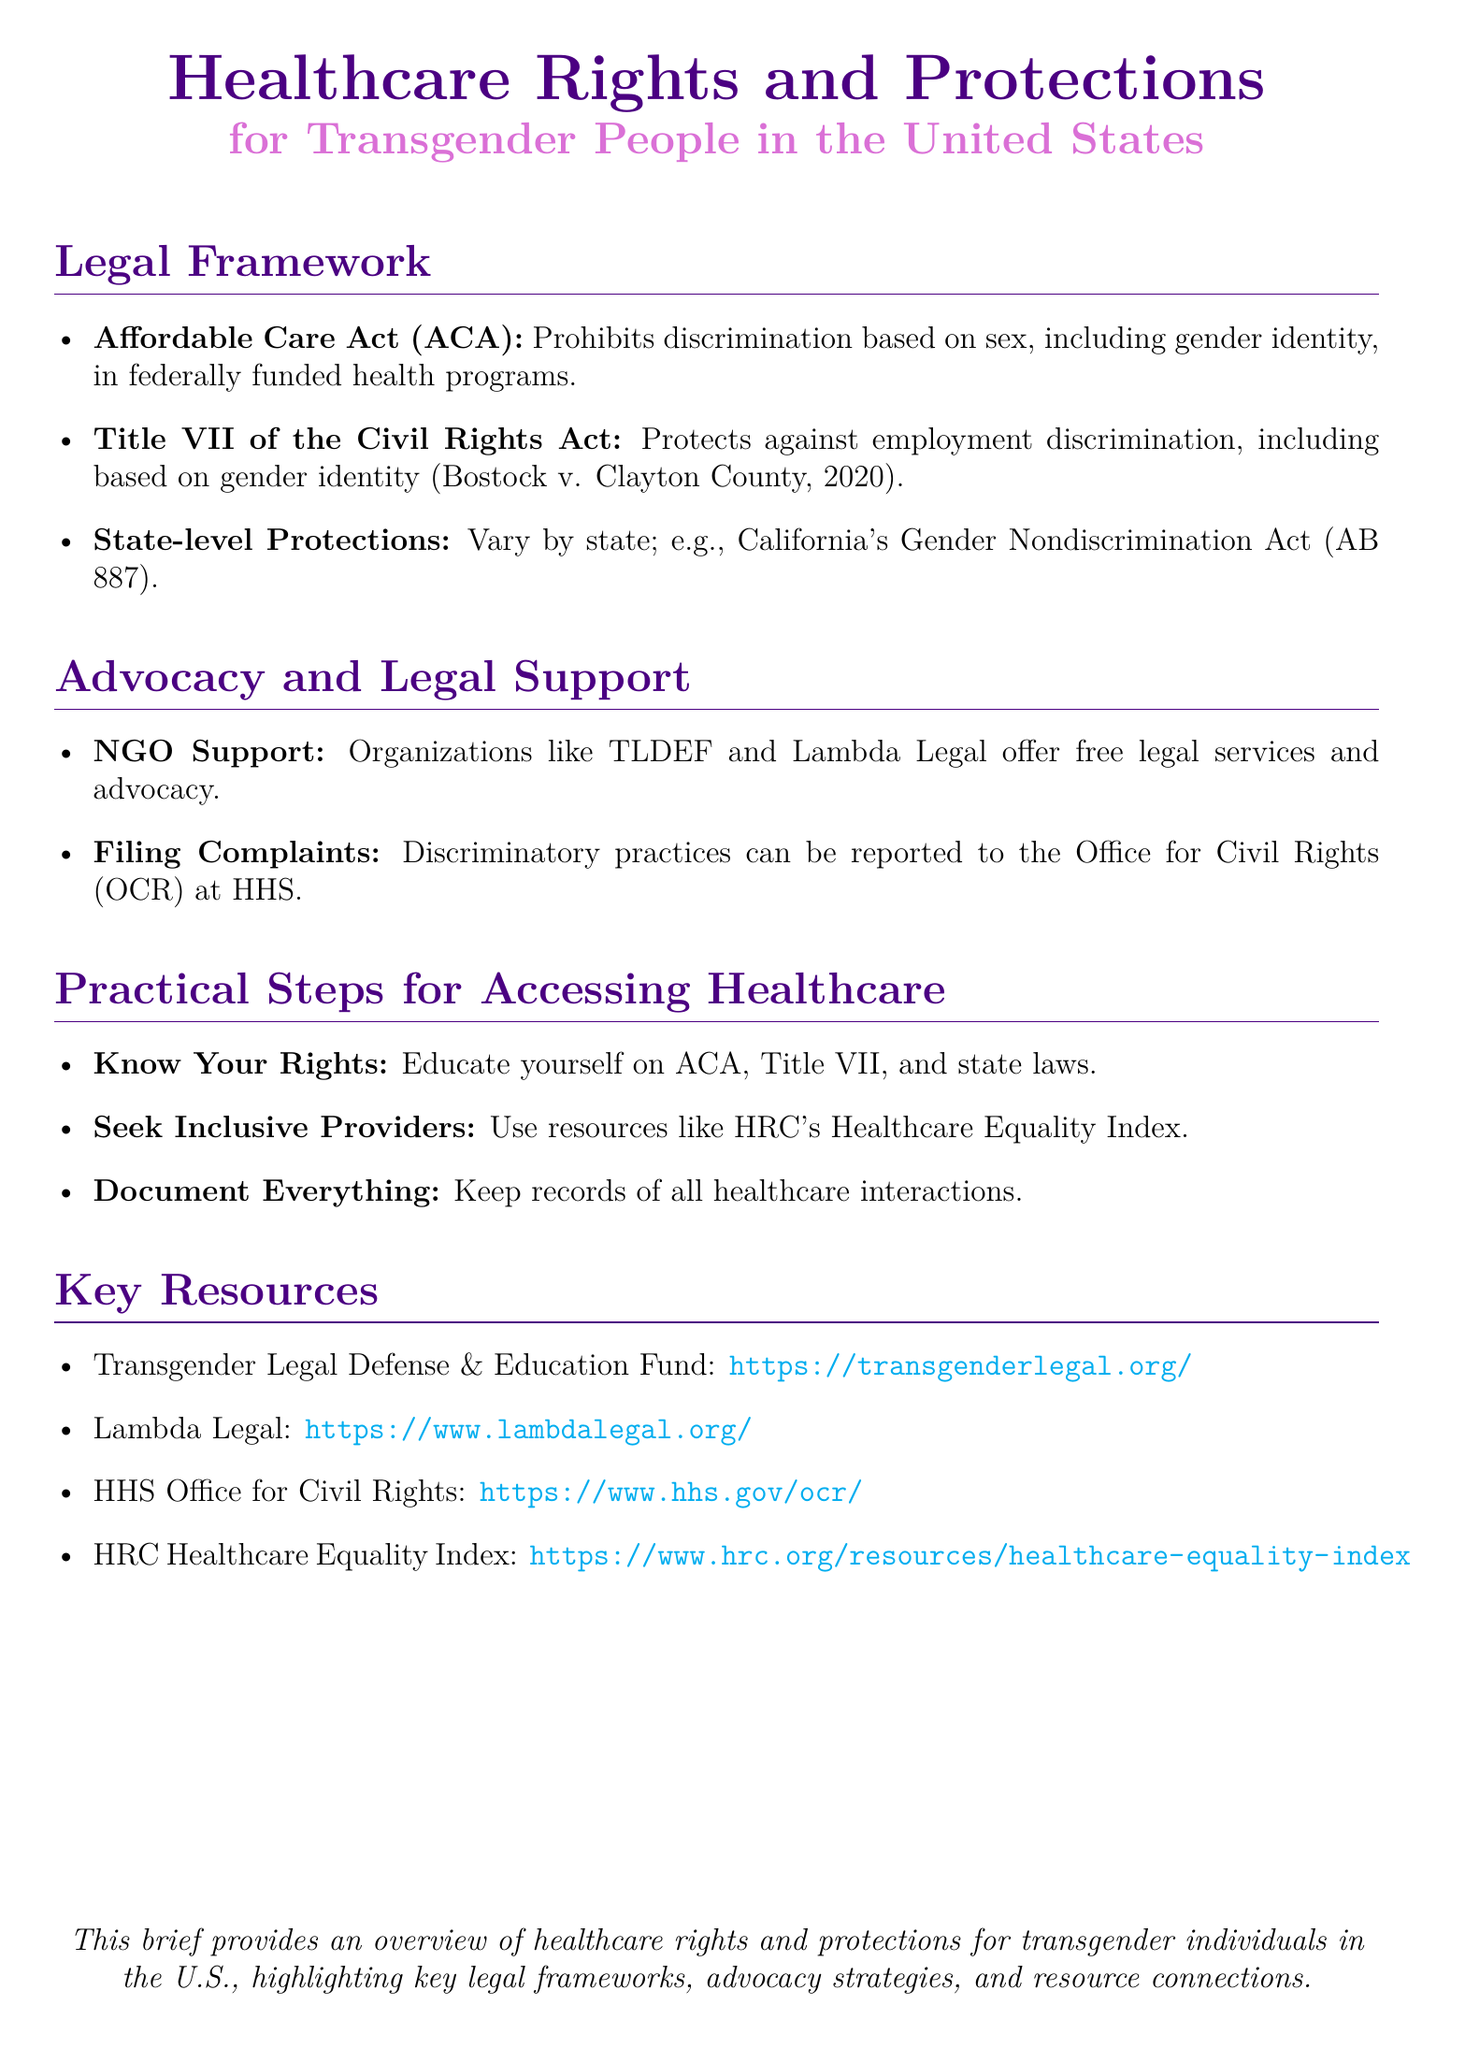What does ACA prohibit? The ACA prohibits discrimination based on sex, including gender identity, in federally funded health programs.
Answer: Discrimination based on sex What is one organization that offers legal support? The document lists organizations that provide legal services to transgender individuals, one of which is TLDEF.
Answer: TLDEF Which act protects against employment discrimination? The document mentions Title VII of the Civil Rights Act as protecting against employment discrimination, specifically noting Bostock v. Clayton County.
Answer: Title VII What should you do to access inclusive healthcare providers? The document suggests using the HRC's Healthcare Equality Index to find inclusive healthcare providers.
Answer: HRC's Healthcare Equality Index How can discriminatory practices be reported? The document states that discriminatory practices can be reported to the Office for Civil Rights at HHS.
Answer: Office for Civil Rights What should you keep records of? The document advises keeping records of all healthcare interactions as a practical step for accessing healthcare.
Answer: Healthcare interactions Where can you find more information about healthcare rights? The document provides several resources, including Lambda Legal and Transgender Legal Defense & Education Fund.
Answer: Lambda Legal What do state-level protections do? The document states that state-level protections vary by state, highlighting California's Gender Nondiscrimination Act as an example.
Answer: Vary by state How does the document categorize its contents? The document is organized into sections such as Legal Framework, Advocacy and Legal Support, Practical Steps, and Key Resources.
Answer: Sections 